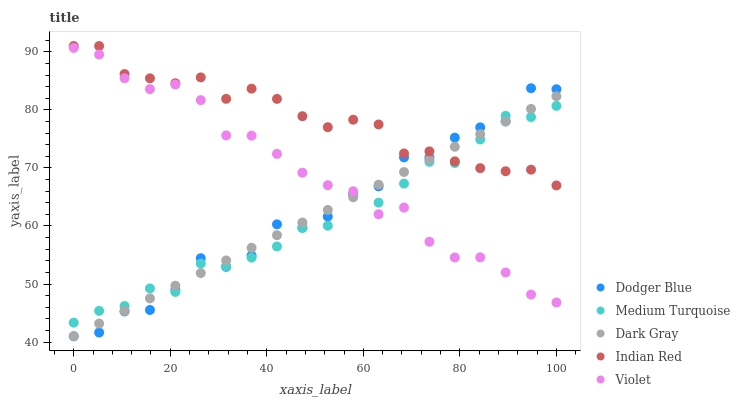Does Medium Turquoise have the minimum area under the curve?
Answer yes or no. Yes. Does Indian Red have the maximum area under the curve?
Answer yes or no. Yes. Does Dodger Blue have the minimum area under the curve?
Answer yes or no. No. Does Dodger Blue have the maximum area under the curve?
Answer yes or no. No. Is Dark Gray the smoothest?
Answer yes or no. Yes. Is Dodger Blue the roughest?
Answer yes or no. Yes. Is Indian Red the smoothest?
Answer yes or no. No. Is Indian Red the roughest?
Answer yes or no. No. Does Dark Gray have the lowest value?
Answer yes or no. Yes. Does Indian Red have the lowest value?
Answer yes or no. No. Does Indian Red have the highest value?
Answer yes or no. Yes. Does Dodger Blue have the highest value?
Answer yes or no. No. Is Violet less than Indian Red?
Answer yes or no. Yes. Is Indian Red greater than Violet?
Answer yes or no. Yes. Does Dark Gray intersect Violet?
Answer yes or no. Yes. Is Dark Gray less than Violet?
Answer yes or no. No. Is Dark Gray greater than Violet?
Answer yes or no. No. Does Violet intersect Indian Red?
Answer yes or no. No. 